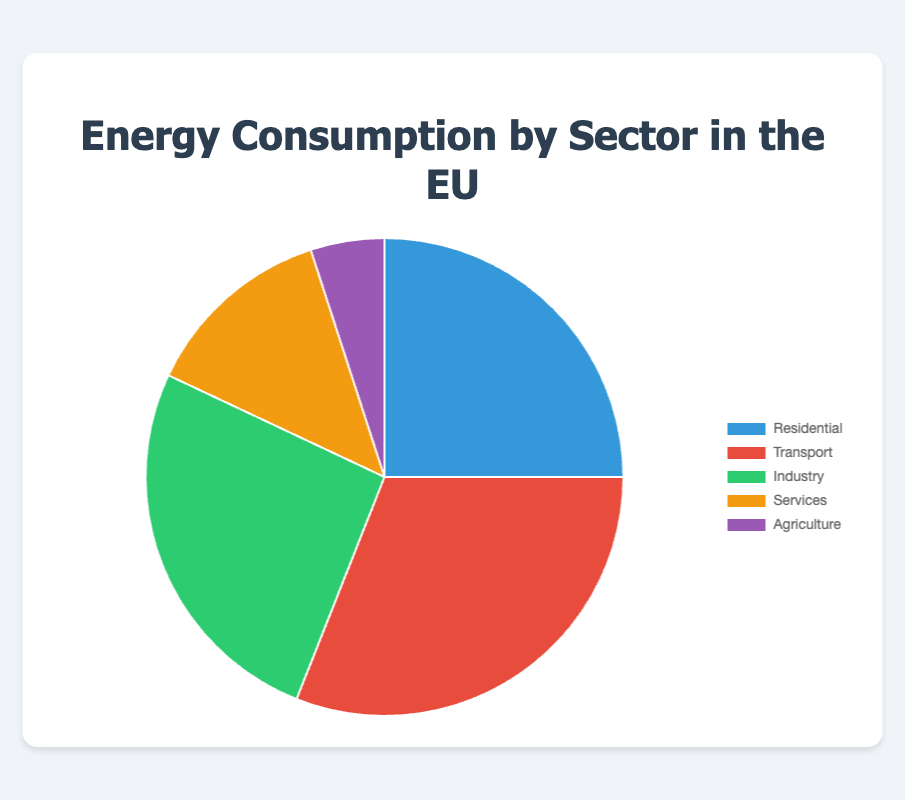Which sector has the highest energy consumption in the EU? The pie chart shows that the Transport sector has the highest percentage at 31%.
Answer: Transport Which sectors combined make up more than half of the EU's energy consumption? Adding the percentages of Transport (31%) and Industry (26%) equals 57%, which is more than half.
Answer: Transport and Industry How much more energy is consumed by the Residential sector compared to the Agriculture sector? The Residential sector consumes 25%, and the Agriculture sector consumes 5%. The difference is 25% - 5% = 20%.
Answer: 20% Which two sectors together account for the smallest portion of the EU's energy consumption? The sectors with the smallest percentages are Agriculture (5%) and Services (13%). Together, they account for 5% + 13% = 18%.
Answer: Agriculture and Services What is the color representation for the Industry sector in the pie chart? The Industry sector is represented by a green color in the pie chart.
Answer: Green What percentage of energy consumption is attributed to sectors other than Transport and Industry? Sectors other than Transport (31%) and Industry (26%) are Residential (25%), Services (13%), and Agriculture (5%). Their combined percentage is 25% + 13% + 5% = 43%.
Answer: 43% If the Services sector's consumption increased by 7%, would it exceed the Residential sector's consumption? The Services sector currently consumes 13%. If it increased by 7%, it would consume 13% + 7% = 20%, which is still less than the Residential sector's 25%.
Answer: No Rank the sectors from highest to lowest energy consumption. Based on the percentages given, the ranking from highest to lowest is Transport (31%), Industry (26%), Residential (25%), Services (13%), and Agriculture (5%).
Answer: Transport, Industry, Residential, Services, Agriculture What is the combined percentage of energy consumption for Residential, Services, and Agriculture sectors? Adding the percentages of Residential (25%), Services (13%), and Agriculture (5%) gives a total of 25% + 13% + 5% = 43%.
Answer: 43% Subtract the energy consumption of the Agriculture sector from that of the Industry sector. The Industry sector consumes 26%, and the Agriculture sector consumes 5%. The difference is 26% - 5% = 21%.
Answer: 21% 